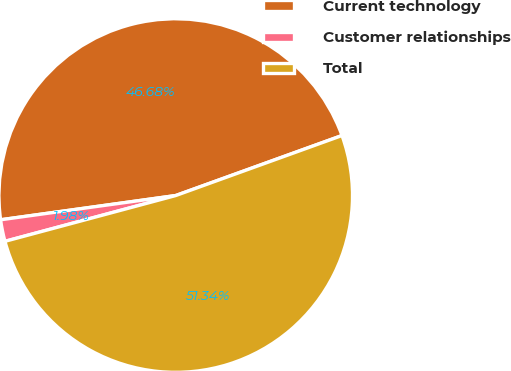<chart> <loc_0><loc_0><loc_500><loc_500><pie_chart><fcel>Current technology<fcel>Customer relationships<fcel>Total<nl><fcel>46.68%<fcel>1.98%<fcel>51.35%<nl></chart> 